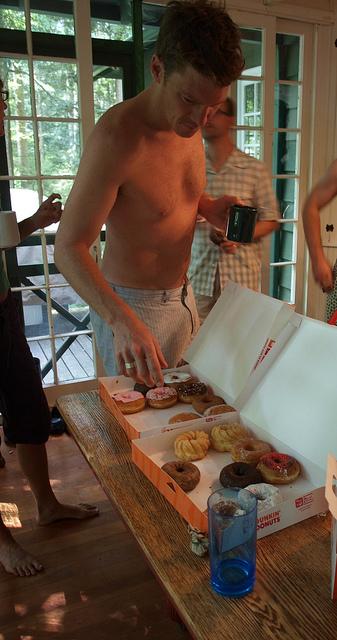Is he a professional food preparer?
Write a very short answer. No. Is the ring on the man's hand a wedding ring?
Quick response, please. No. How many doughnuts are there?
Keep it brief. 16. What meal is he eating?
Give a very brief answer. Breakfast. Where are the donuts from?
Short answer required. Dunkin donuts. 